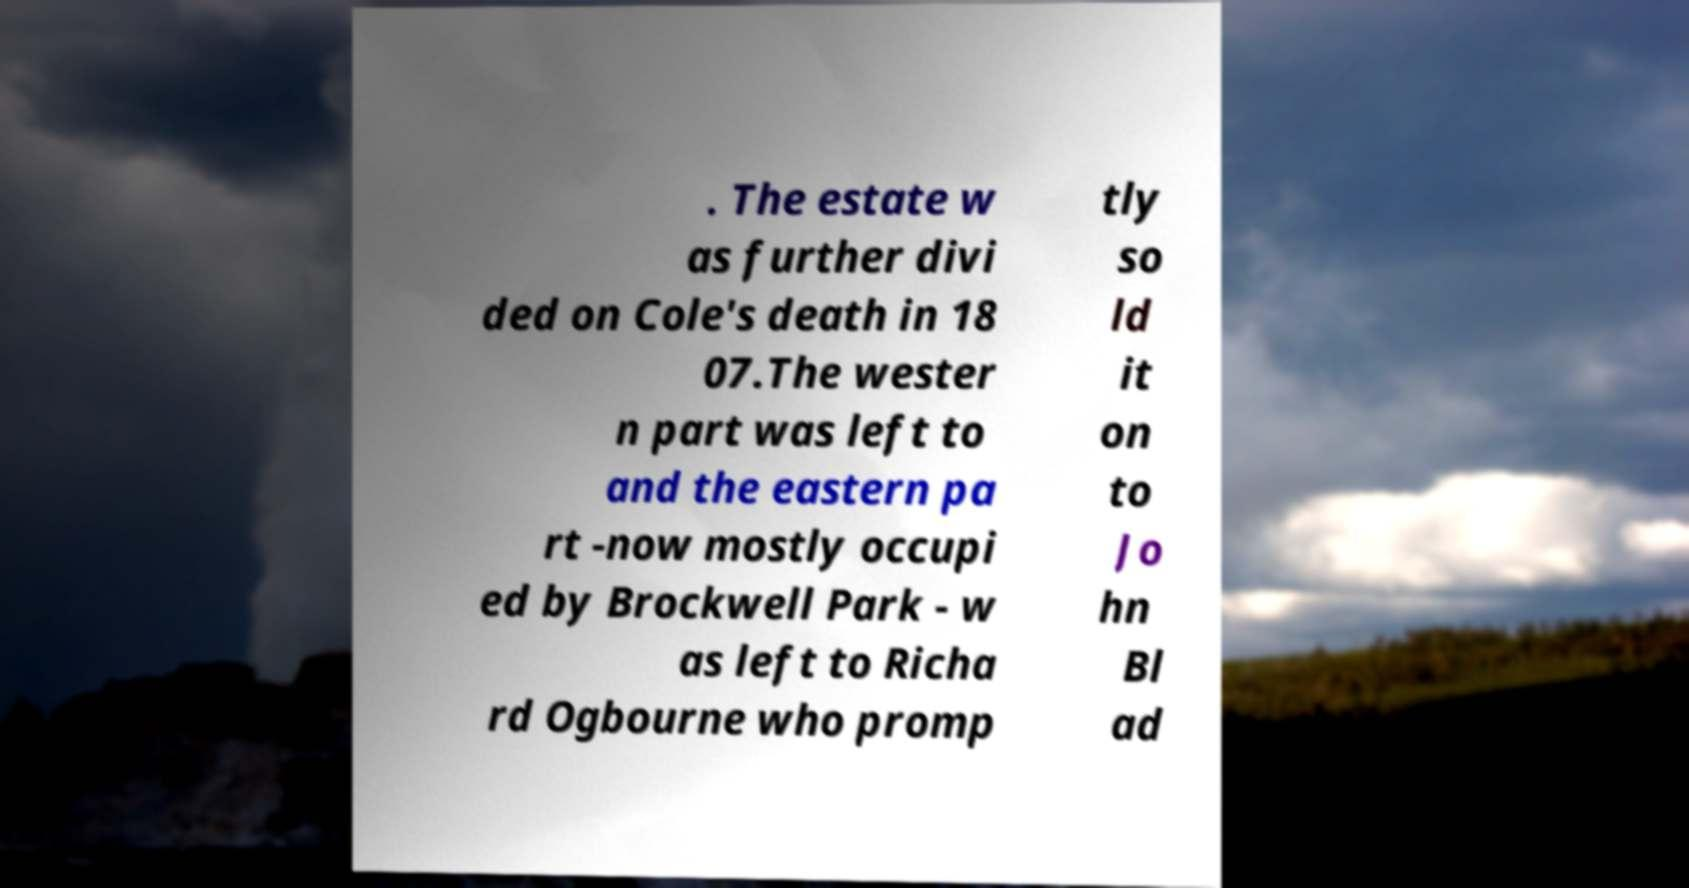There's text embedded in this image that I need extracted. Can you transcribe it verbatim? . The estate w as further divi ded on Cole's death in 18 07.The wester n part was left to and the eastern pa rt -now mostly occupi ed by Brockwell Park - w as left to Richa rd Ogbourne who promp tly so ld it on to Jo hn Bl ad 